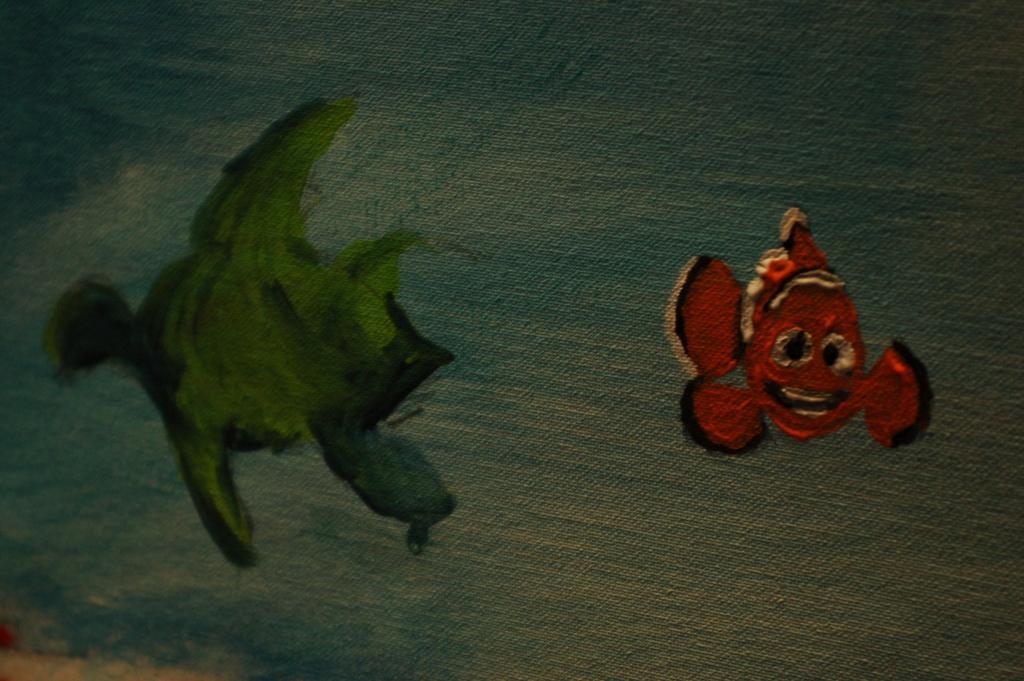Can you describe this image briefly? In this image I can see a painting of two fishes, they are in orange, black and green color and background is in blue and white color. 